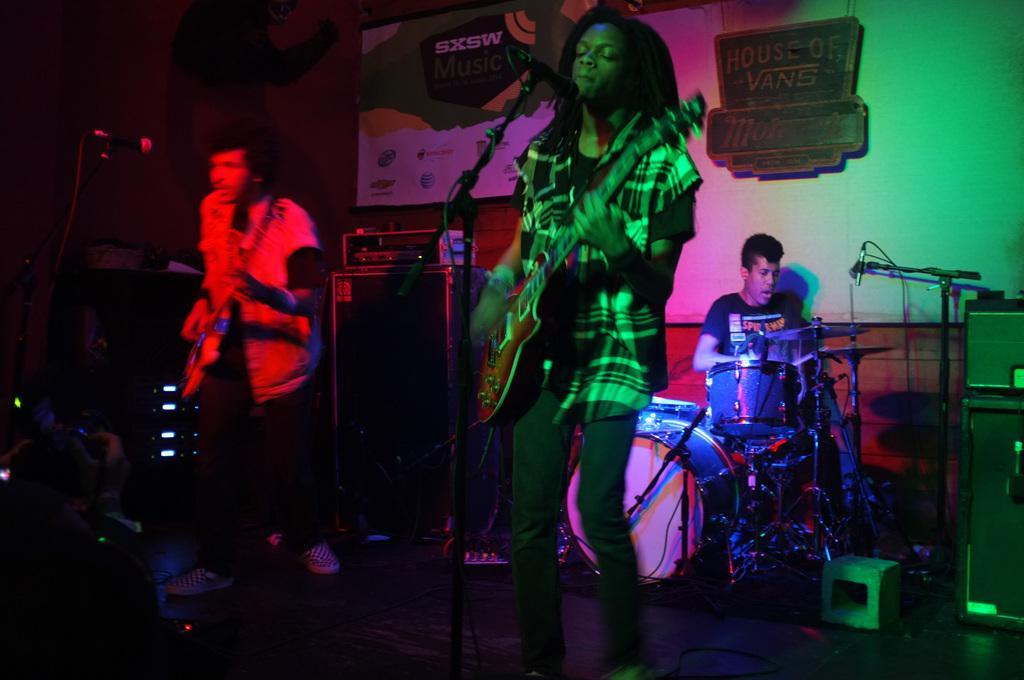Please provide a concise description of this image. There is girl and a boy holding guitars in their hands and standing in front of the mics in the foreground area of the image, there is a boy sitting in front of a drum set and a mic, it seems like posters and other objects in the background. 